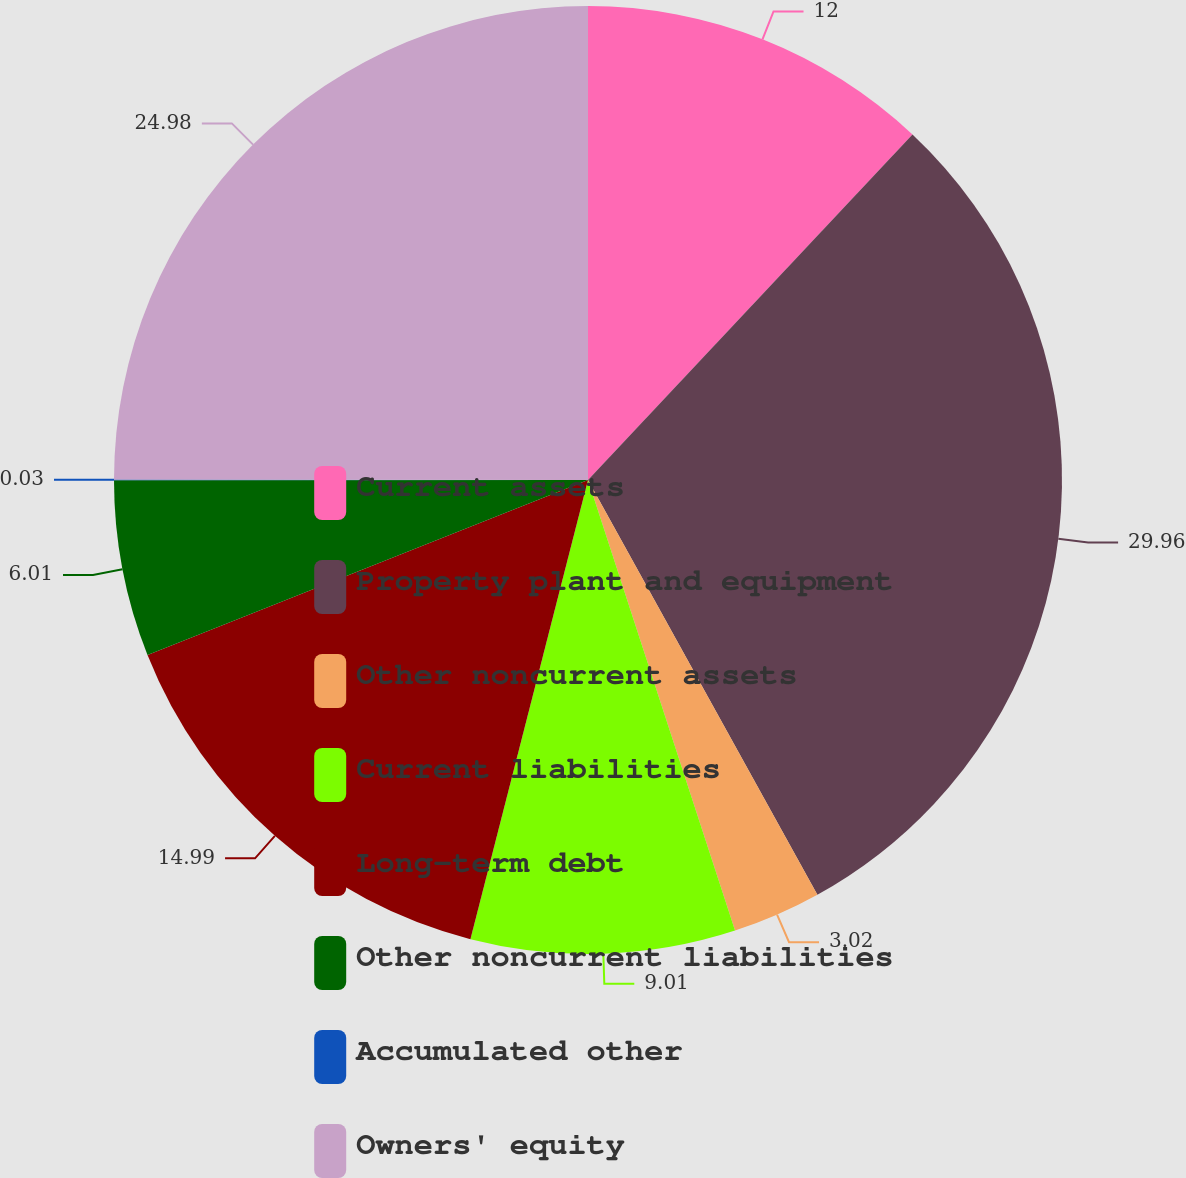Convert chart. <chart><loc_0><loc_0><loc_500><loc_500><pie_chart><fcel>Current assets<fcel>Property plant and equipment<fcel>Other noncurrent assets<fcel>Current liabilities<fcel>Long-term debt<fcel>Other noncurrent liabilities<fcel>Accumulated other<fcel>Owners' equity<nl><fcel>12.0%<fcel>29.96%<fcel>3.02%<fcel>9.01%<fcel>14.99%<fcel>6.01%<fcel>0.03%<fcel>24.98%<nl></chart> 